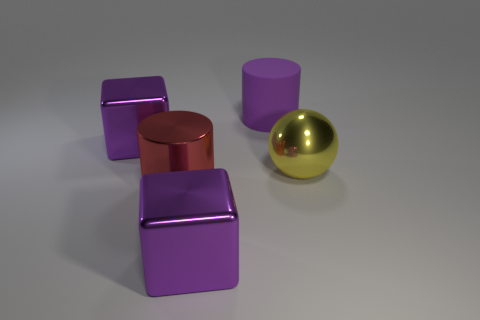Add 3 large purple shiny things. How many objects exist? 8 Subtract all cylinders. How many objects are left? 3 Subtract 1 cylinders. How many cylinders are left? 1 Subtract 0 yellow blocks. How many objects are left? 5 Subtract all green blocks. Subtract all purple balls. How many blocks are left? 2 Subtract all big matte objects. Subtract all yellow shiny things. How many objects are left? 3 Add 2 large purple objects. How many large purple objects are left? 5 Add 2 tiny green rubber cubes. How many tiny green rubber cubes exist? 2 Subtract all red cylinders. How many cylinders are left? 1 